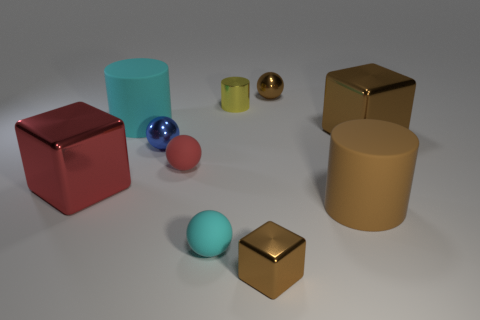Which objects in the image have reflective surfaces? The gold and blue spherical objects and the golden cube have reflective surfaces. Their shininess suggests they might be made of metallic materials, as they reflect the environment and light sources around them. 